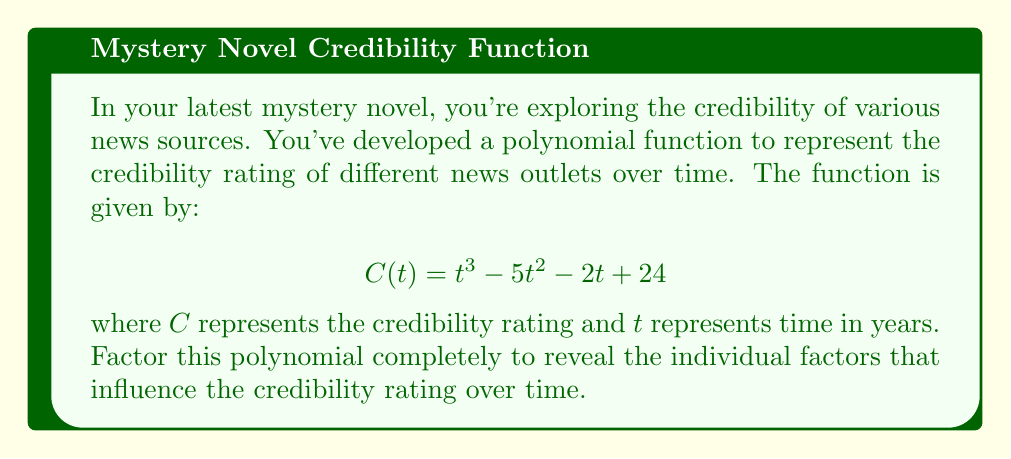Solve this math problem. To factor this cubic polynomial, we'll follow these steps:

1) First, let's check if there are any rational roots using the rational root theorem. The possible rational roots are the factors of the constant term: ±1, ±2, ±3, ±4, ±6, ±8, ±12, ±24.

2) By testing these values, we find that $t = 4$ is a root of the polynomial. So $(t - 4)$ is a factor.

3) We can use polynomial long division to divide $C(t)$ by $(t - 4)$:

   $$t^3 - 5t^2 - 2t + 24 = (t - 4)(t^2 + t - 6)$$

4) Now we need to factor the quadratic term $t^2 + t - 6$. We can do this by finding two numbers that multiply to give -6 and add to give 1.

5) These numbers are 3 and -2. So we can factor $t^2 + t - 6$ as $(t + 3)(t - 2)$.

6) Combining all factors, we get:

   $$C(t) = (t - 4)(t + 3)(t - 2)$$

This factorization reveals that the credibility function has three roots: 4, -3, and 2, representing critical points in time where the credibility rating becomes zero.
Answer: $(t - 4)(t + 3)(t - 2)$ 